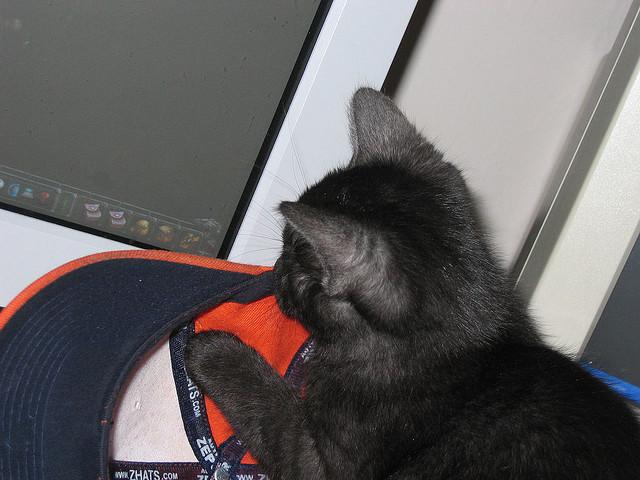Is this a full grown cat?
Be succinct. No. What is the cat touching?
Write a very short answer. Hat. What is the cat looking at?
Answer briefly. Monitor. 